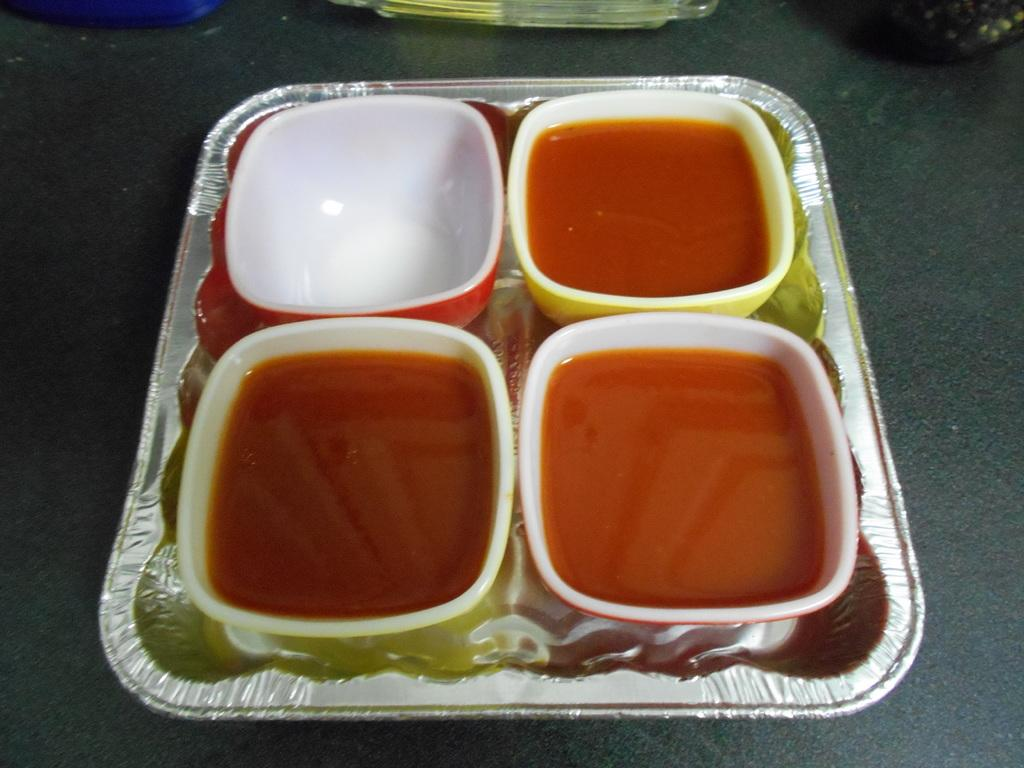What is in the bowls that are visible in the image? There are food items in the bowls. How many bowls are present in the tray? There are four bowls in the tray. What can be seen at the back of the image? There are objects at the back of the image. What surface is visible at the bottom of the image? There is a floor visible at the bottom of the image. What type of friction can be observed between the food items and the bowls in the image? There is no information about friction between the food items and the bowls in the image. --- Facts: 1. There is a person sitting on a chair. 2. The person is holding a book. 3. There is a table next to the chair. 4. There is a lamp on the table. 5. The background of the image is a wall. Absurd Topics: parrot, ocean, bicycle Conversation: What is the person in the image doing? The person is sitting on a chair. What is the person holding in the image? The person is holding a book. What is located next to the chair in the image? There is a table next to the chair. What object is on the table in the image? There is a lamp on the table. What can be seen behind the person in the image? The background of the image is a wall. Reasoning: Let's think step by step in order to produce the conversation. We start by identifying the main subject in the image, which is the person sitting on a chair. Then, we expand the conversation to include details about the book the person is holding, the table and lamp next to the chair, and the wall in the background. Each question is designed to elicit a specific detail about the image that is known from the provided facts. Absurd Question/Answer: Can you see any parrots flying over the ocean in the image? There is no mention of parrots or the ocean in the image; it features a person sitting on a chair with a book, a table, a lamp, and a wall in the background. 